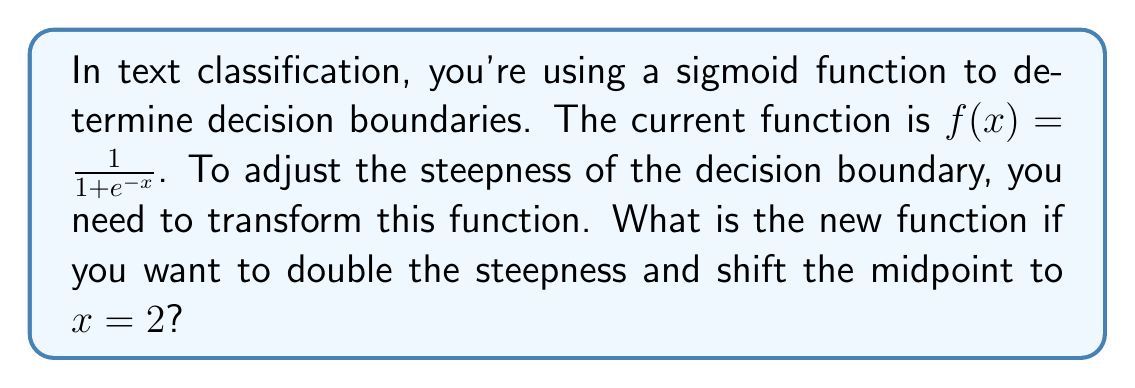Can you solve this math problem? To solve this problem, we'll follow these steps:

1) The standard sigmoid function is:
   $$f(x) = \frac{1}{1 + e^{-x}}$$

2) To double the steepness, we multiply the input by 2:
   $$f(x) = \frac{1}{1 + e^{-2x}}$$

3) To shift the midpoint to $x = 2$, we subtract 2 from the input:
   $$f(x) = \frac{1}{1 + e^{-2(x-2)}}$$

4) Simplify the expression inside the exponential:
   $$f(x) = \frac{1}{1 + e^{-2x+4}}$$

This new function will have twice the steepness of the original sigmoid function and its midpoint (where $f(x) = 0.5$) will be at $x = 2$.
Answer: $f(x) = \frac{1}{1 + e^{-2x+4}}$ 